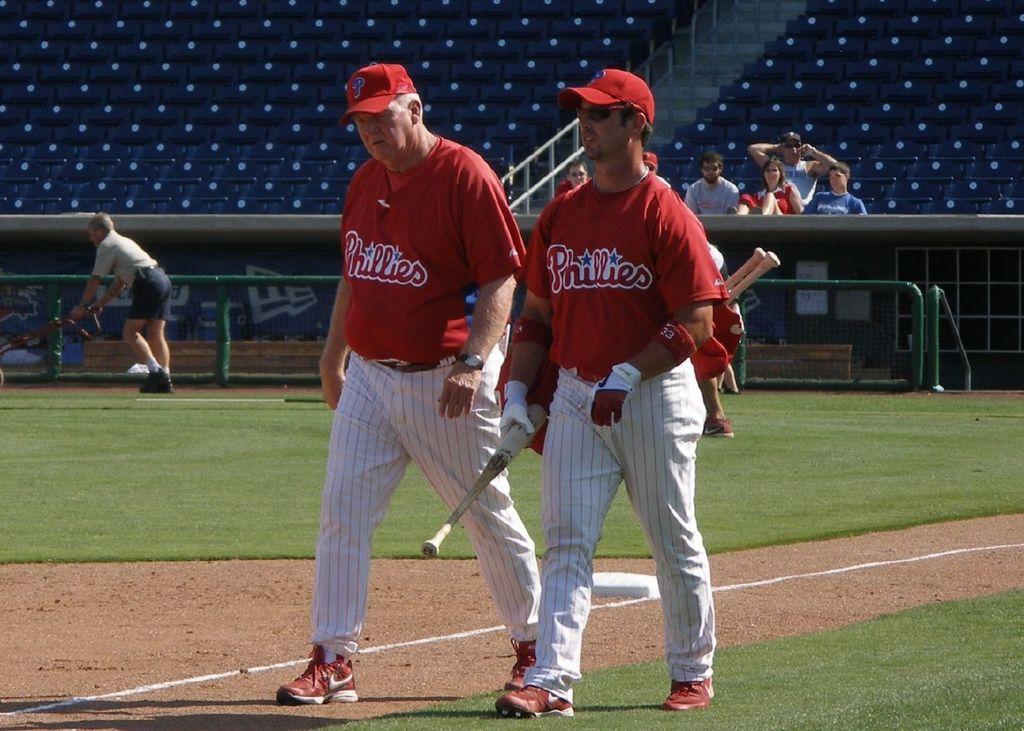What number does the player on the right have on his red wristband?
Provide a short and direct response. 33. 